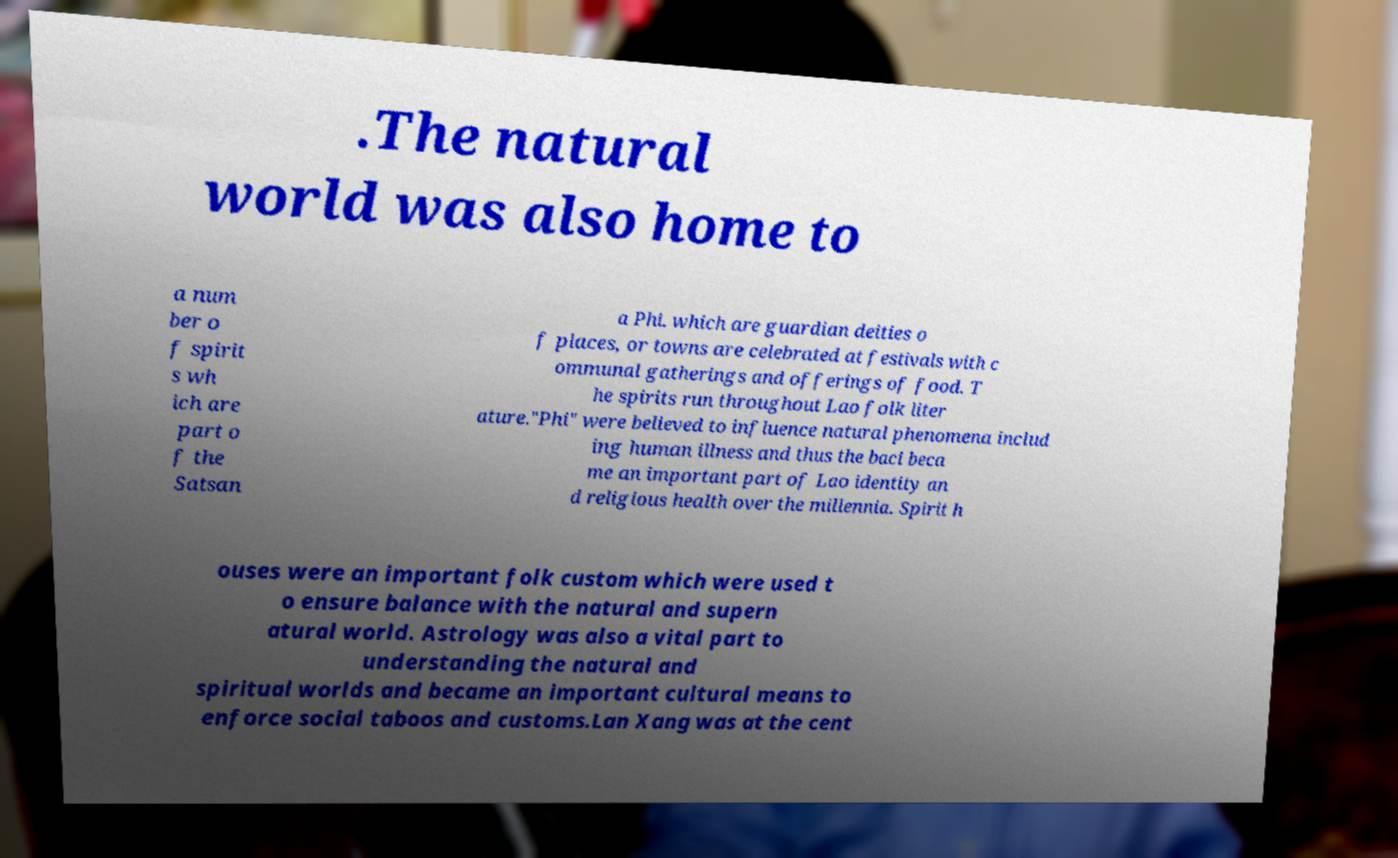For documentation purposes, I need the text within this image transcribed. Could you provide that? .The natural world was also home to a num ber o f spirit s wh ich are part o f the Satsan a Phi. which are guardian deities o f places, or towns are celebrated at festivals with c ommunal gatherings and offerings of food. T he spirits run throughout Lao folk liter ature."Phi" were believed to influence natural phenomena includ ing human illness and thus the baci beca me an important part of Lao identity an d religious health over the millennia. Spirit h ouses were an important folk custom which were used t o ensure balance with the natural and supern atural world. Astrology was also a vital part to understanding the natural and spiritual worlds and became an important cultural means to enforce social taboos and customs.Lan Xang was at the cent 